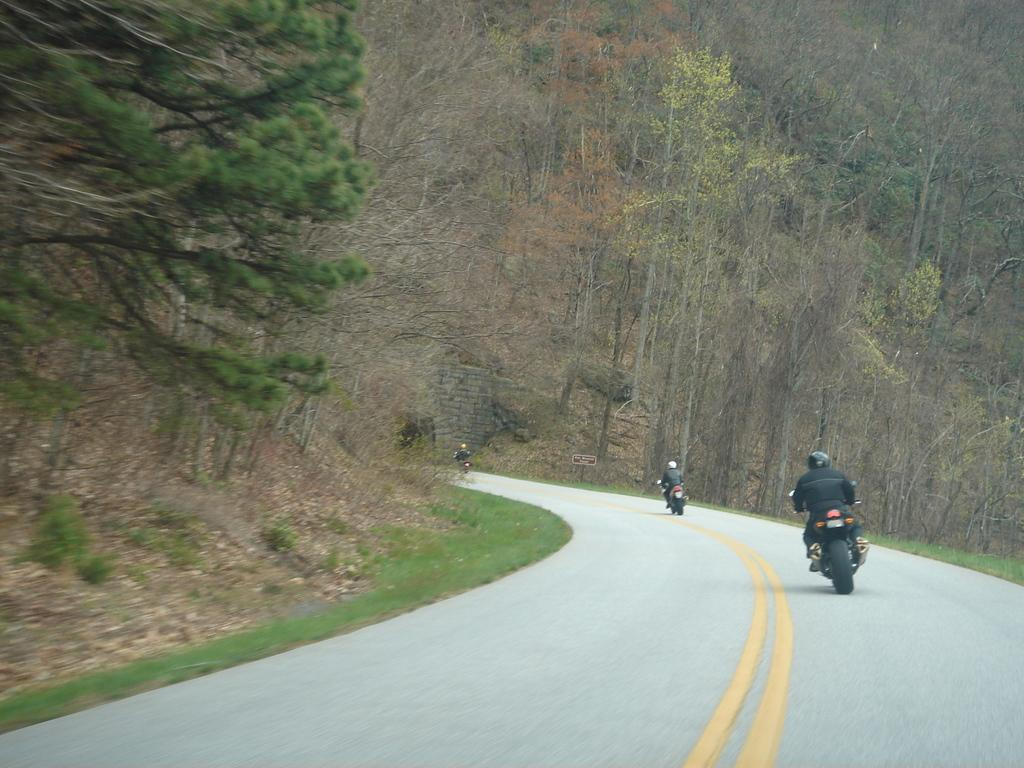What are the persons in the image doing? The persons in the image are sitting on motor vehicles. Where are the motor vehicles located? The motor vehicles are on the road. What type of vegetation can be seen in the image? There is grass visible in the image, and there are trees as well. What else can be seen on the ground in the image? There are shredded leaves in the image. What type of income can be seen in the image? There is no reference to income in the image; it features persons sitting on motor vehicles on the road, with grass, shredded leaves, and trees visible. What type of underwear is the person on the motorcycle wearing? There is no information about the person's underwear in the image, as it focuses on the motor vehicles and their surroundings. 